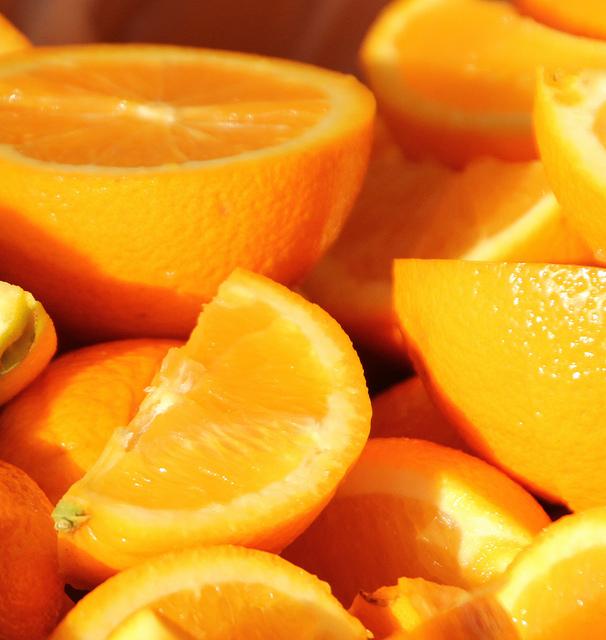What kind of fruit is this?
Give a very brief answer. Orange. Do you see seeds in the fruits?
Give a very brief answer. No. Are the oranges whole or in segments?
Quick response, please. Segments. 